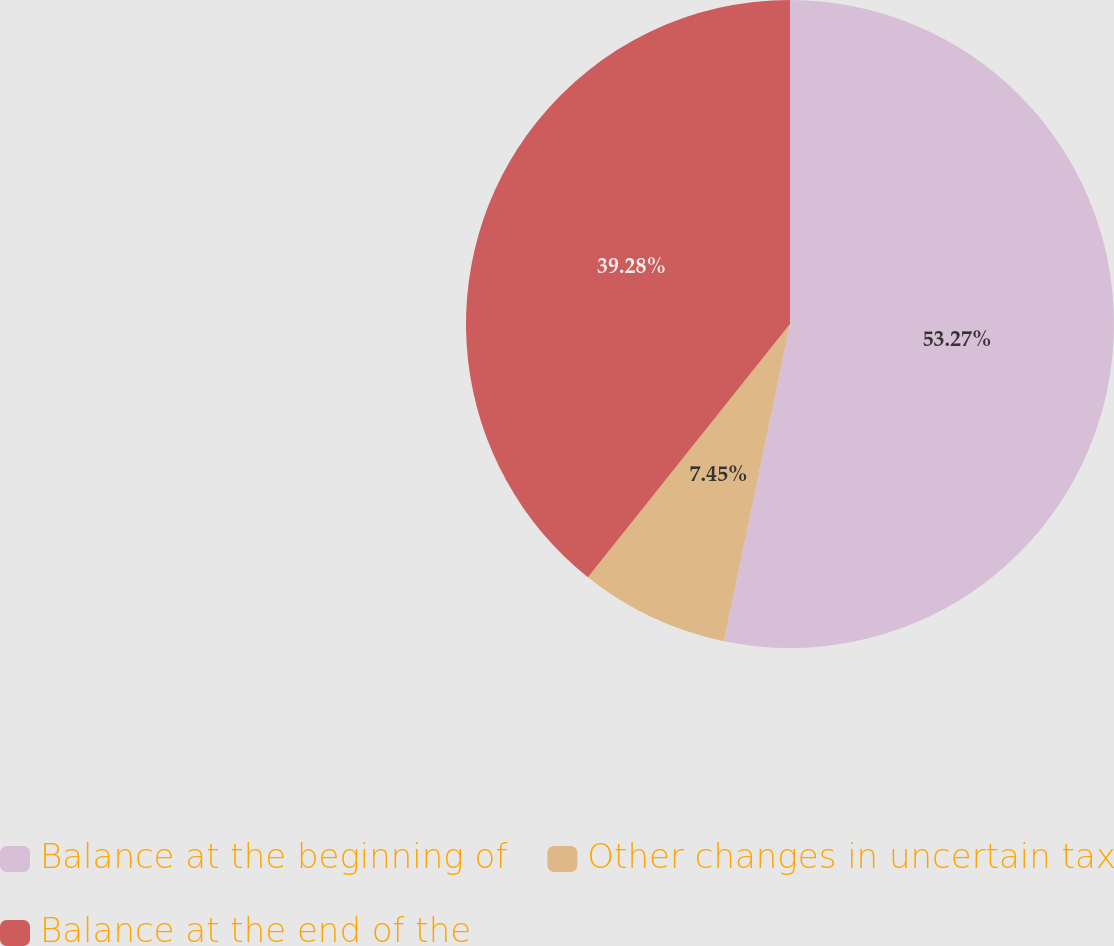<chart> <loc_0><loc_0><loc_500><loc_500><pie_chart><fcel>Balance at the beginning of<fcel>Other changes in uncertain tax<fcel>Balance at the end of the<nl><fcel>53.27%<fcel>7.45%<fcel>39.28%<nl></chart> 